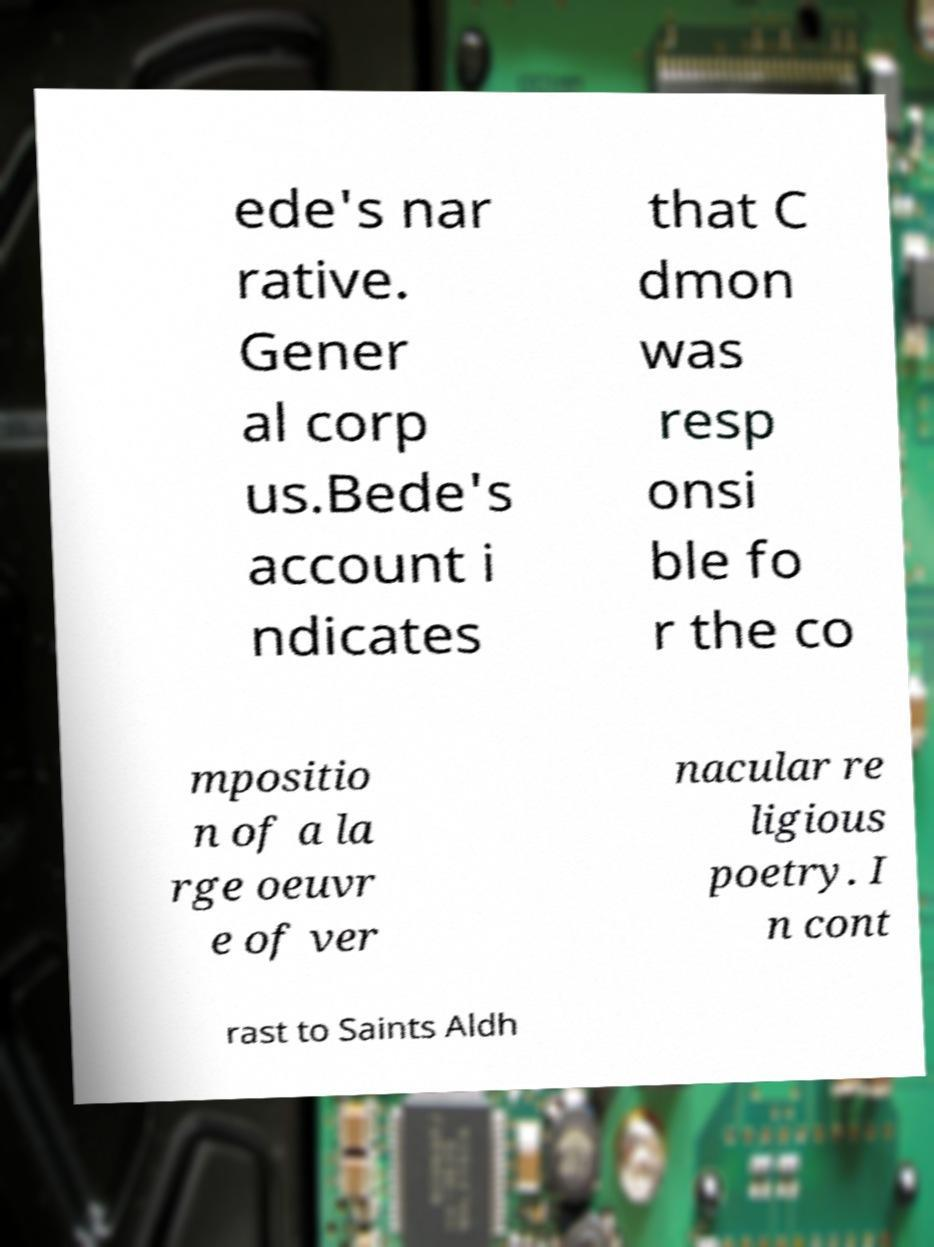Could you assist in decoding the text presented in this image and type it out clearly? ede's nar rative. Gener al corp us.Bede's account i ndicates that C dmon was resp onsi ble fo r the co mpositio n of a la rge oeuvr e of ver nacular re ligious poetry. I n cont rast to Saints Aldh 